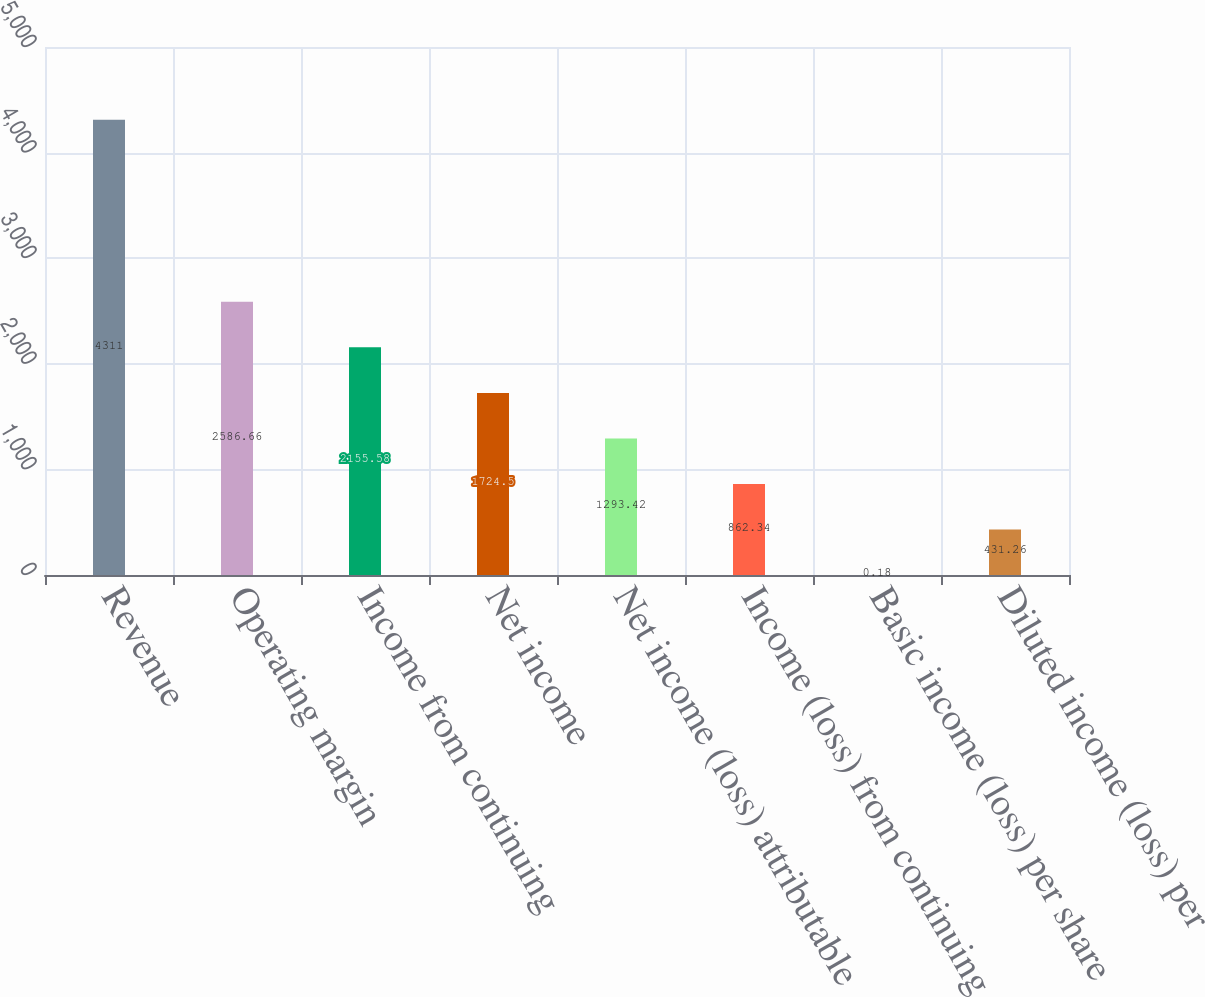Convert chart to OTSL. <chart><loc_0><loc_0><loc_500><loc_500><bar_chart><fcel>Revenue<fcel>Operating margin<fcel>Income from continuing<fcel>Net income<fcel>Net income (loss) attributable<fcel>Income (loss) from continuing<fcel>Basic income (loss) per share<fcel>Diluted income (loss) per<nl><fcel>4311<fcel>2586.66<fcel>2155.58<fcel>1724.5<fcel>1293.42<fcel>862.34<fcel>0.18<fcel>431.26<nl></chart> 